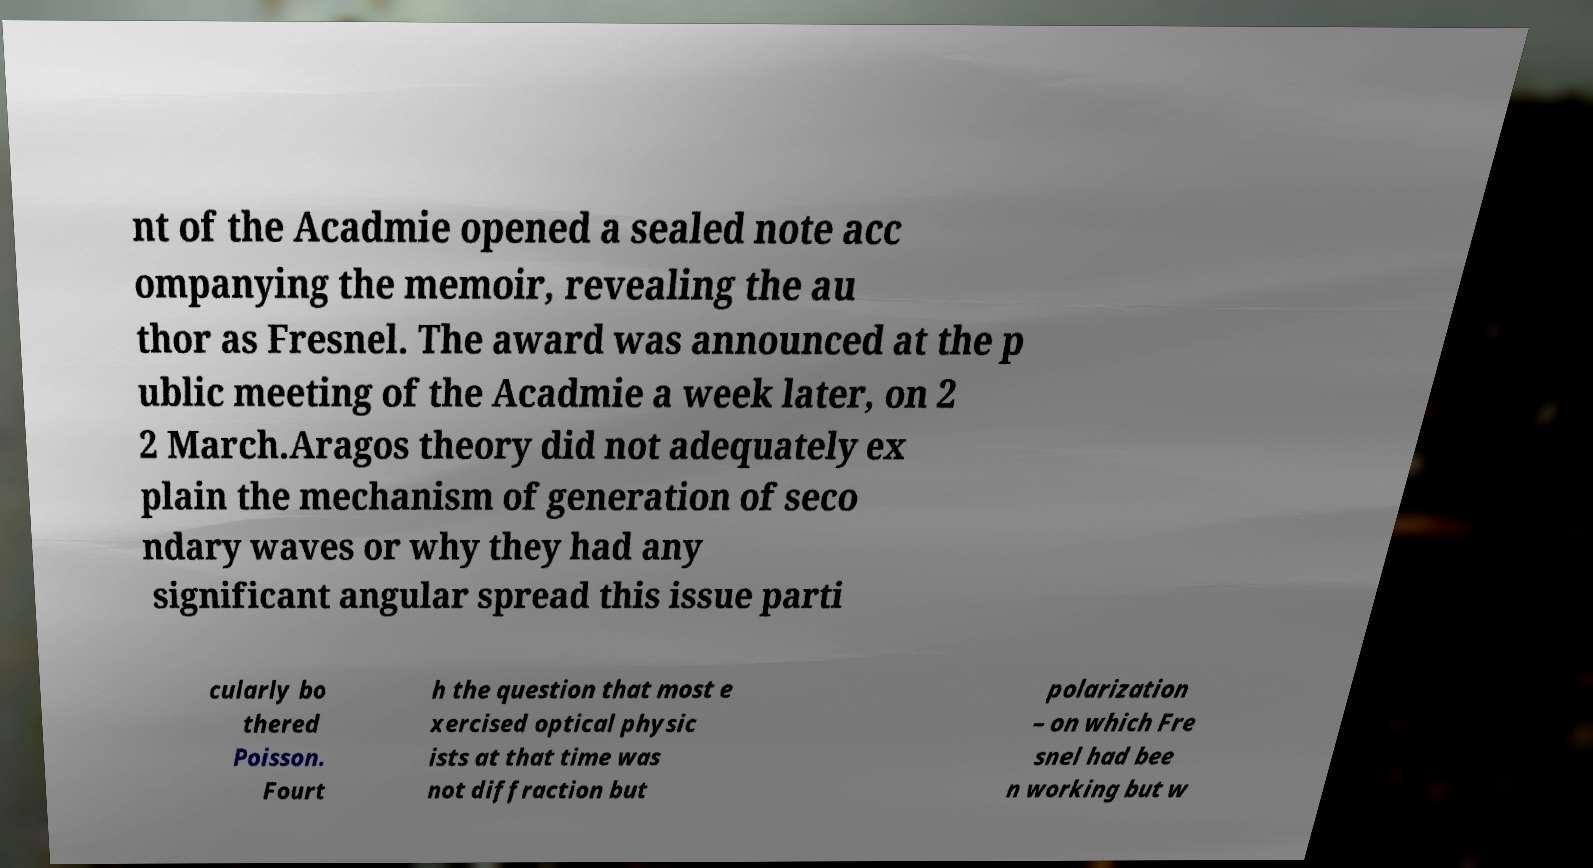Please read and relay the text visible in this image. What does it say? nt of the Acadmie opened a sealed note acc ompanying the memoir, revealing the au thor as Fresnel. The award was announced at the p ublic meeting of the Acadmie a week later, on 2 2 March.Aragos theory did not adequately ex plain the mechanism of generation of seco ndary waves or why they had any significant angular spread this issue parti cularly bo thered Poisson. Fourt h the question that most e xercised optical physic ists at that time was not diffraction but polarization – on which Fre snel had bee n working but w 